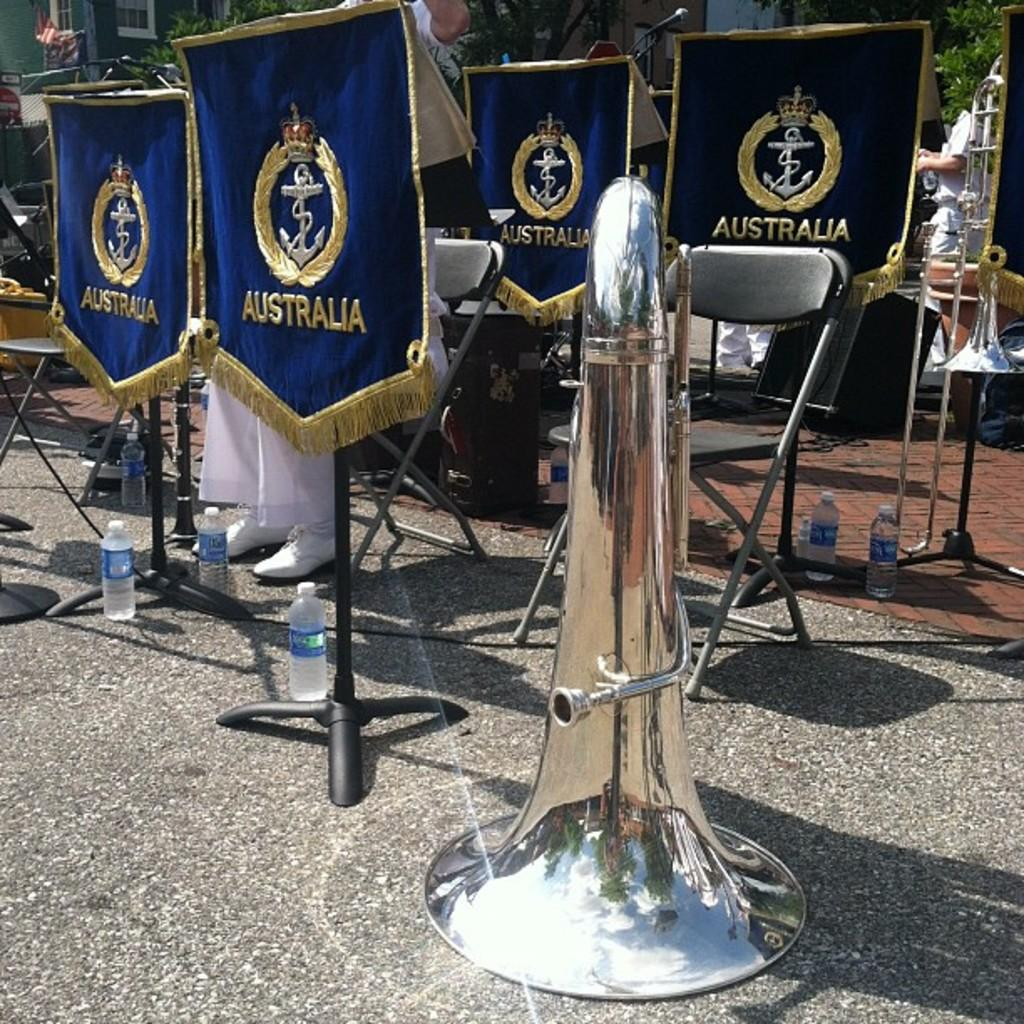What objects can be seen in the image related to music? There are music instruments in the image. What type of furniture is present in the image? There are chairs in the image. What structures are visible in the image for holding or displaying items? There are stands in the image. What type of clothing can be seen in the image? There are clothes in the image. Are there any people present in the image? Yes, there are people in the image. What type of containers are visible in the image? There are bottles in the image. What type of respect can be seen being given to the dinner in the image? There is no dinner present in the image, so it is not possible to determine if any respect is being given. What type of theory is being discussed by the people in the image? There is no indication in the image that a theory is being discussed, so it cannot be determined from the picture. 